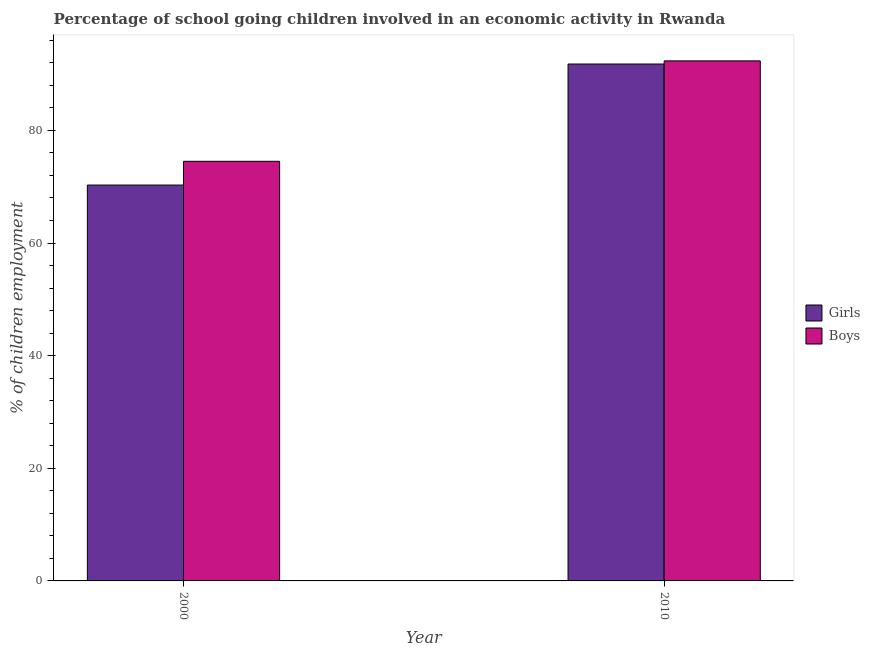How many bars are there on the 1st tick from the left?
Offer a terse response. 2. How many bars are there on the 2nd tick from the right?
Your answer should be compact. 2. What is the label of the 2nd group of bars from the left?
Keep it short and to the point. 2010. In how many cases, is the number of bars for a given year not equal to the number of legend labels?
Keep it short and to the point. 0. What is the percentage of school going girls in 2000?
Offer a very short reply. 70.3. Across all years, what is the maximum percentage of school going girls?
Your answer should be compact. 91.79. Across all years, what is the minimum percentage of school going girls?
Provide a succinct answer. 70.3. What is the total percentage of school going girls in the graph?
Offer a terse response. 162.09. What is the difference between the percentage of school going girls in 2000 and that in 2010?
Provide a short and direct response. -21.49. What is the difference between the percentage of school going girls in 2010 and the percentage of school going boys in 2000?
Provide a succinct answer. 21.49. What is the average percentage of school going girls per year?
Ensure brevity in your answer.  81.04. In the year 2010, what is the difference between the percentage of school going girls and percentage of school going boys?
Give a very brief answer. 0. What is the ratio of the percentage of school going boys in 2000 to that in 2010?
Provide a succinct answer. 0.81. What does the 2nd bar from the left in 2010 represents?
Your answer should be very brief. Boys. What does the 1st bar from the right in 2000 represents?
Offer a terse response. Boys. What is the difference between two consecutive major ticks on the Y-axis?
Provide a succinct answer. 20. Are the values on the major ticks of Y-axis written in scientific E-notation?
Provide a succinct answer. No. Does the graph contain any zero values?
Offer a very short reply. No. Where does the legend appear in the graph?
Make the answer very short. Center right. How many legend labels are there?
Keep it short and to the point. 2. How are the legend labels stacked?
Your answer should be very brief. Vertical. What is the title of the graph?
Your answer should be very brief. Percentage of school going children involved in an economic activity in Rwanda. What is the label or title of the X-axis?
Offer a terse response. Year. What is the label or title of the Y-axis?
Offer a very short reply. % of children employment. What is the % of children employment in Girls in 2000?
Provide a short and direct response. 70.3. What is the % of children employment in Boys in 2000?
Make the answer very short. 74.52. What is the % of children employment in Girls in 2010?
Provide a short and direct response. 91.79. What is the % of children employment of Boys in 2010?
Ensure brevity in your answer.  92.35. Across all years, what is the maximum % of children employment of Girls?
Your response must be concise. 91.79. Across all years, what is the maximum % of children employment of Boys?
Your answer should be compact. 92.35. Across all years, what is the minimum % of children employment of Girls?
Offer a terse response. 70.3. Across all years, what is the minimum % of children employment in Boys?
Provide a succinct answer. 74.52. What is the total % of children employment of Girls in the graph?
Your answer should be compact. 162.09. What is the total % of children employment in Boys in the graph?
Offer a very short reply. 166.87. What is the difference between the % of children employment in Girls in 2000 and that in 2010?
Your answer should be compact. -21.49. What is the difference between the % of children employment of Boys in 2000 and that in 2010?
Provide a succinct answer. -17.83. What is the difference between the % of children employment in Girls in 2000 and the % of children employment in Boys in 2010?
Ensure brevity in your answer.  -22.05. What is the average % of children employment of Girls per year?
Your answer should be compact. 81.04. What is the average % of children employment in Boys per year?
Your answer should be compact. 83.43. In the year 2000, what is the difference between the % of children employment of Girls and % of children employment of Boys?
Ensure brevity in your answer.  -4.22. In the year 2010, what is the difference between the % of children employment in Girls and % of children employment in Boys?
Your response must be concise. -0.56. What is the ratio of the % of children employment in Girls in 2000 to that in 2010?
Provide a succinct answer. 0.77. What is the ratio of the % of children employment of Boys in 2000 to that in 2010?
Keep it short and to the point. 0.81. What is the difference between the highest and the second highest % of children employment in Girls?
Keep it short and to the point. 21.49. What is the difference between the highest and the second highest % of children employment in Boys?
Give a very brief answer. 17.83. What is the difference between the highest and the lowest % of children employment of Girls?
Give a very brief answer. 21.49. What is the difference between the highest and the lowest % of children employment in Boys?
Offer a terse response. 17.83. 